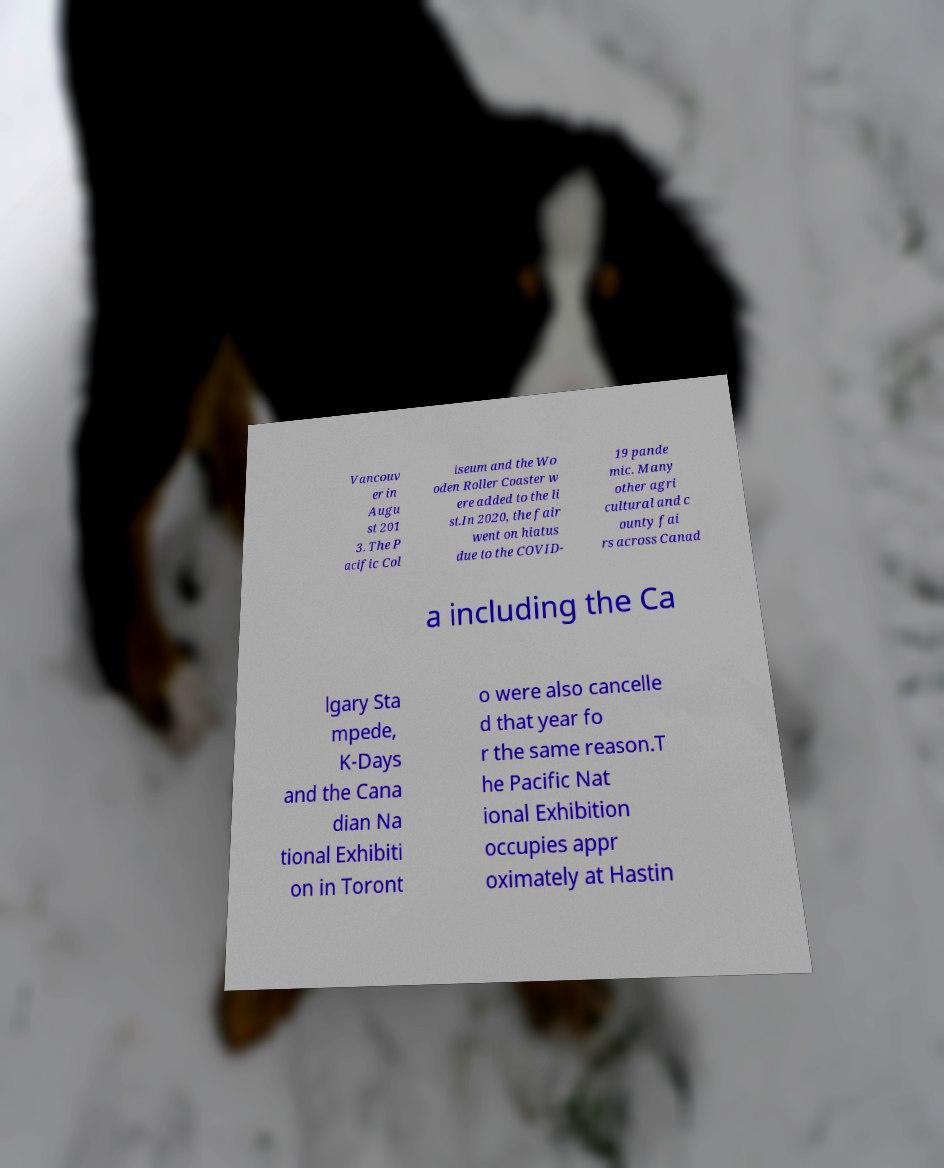There's text embedded in this image that I need extracted. Can you transcribe it verbatim? Vancouv er in Augu st 201 3. The P acific Col iseum and the Wo oden Roller Coaster w ere added to the li st.In 2020, the fair went on hiatus due to the COVID- 19 pande mic. Many other agri cultural and c ounty fai rs across Canad a including the Ca lgary Sta mpede, K-Days and the Cana dian Na tional Exhibiti on in Toront o were also cancelle d that year fo r the same reason.T he Pacific Nat ional Exhibition occupies appr oximately at Hastin 